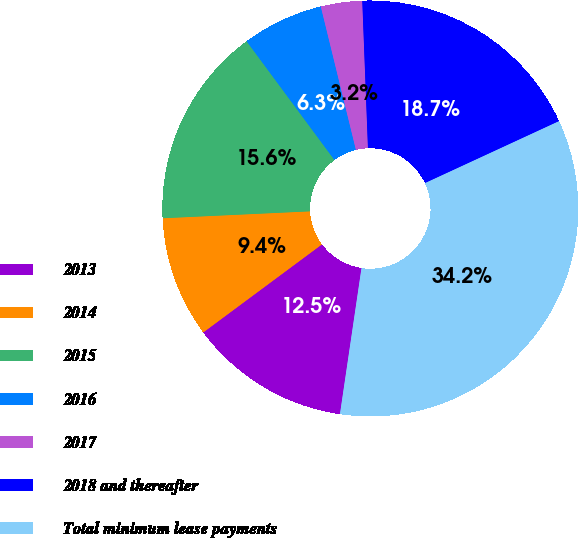Convert chart to OTSL. <chart><loc_0><loc_0><loc_500><loc_500><pie_chart><fcel>2013<fcel>2014<fcel>2015<fcel>2016<fcel>2017<fcel>2018 and thereafter<fcel>Total minimum lease payments<nl><fcel>12.51%<fcel>9.41%<fcel>15.61%<fcel>6.31%<fcel>3.21%<fcel>18.72%<fcel>34.22%<nl></chart> 